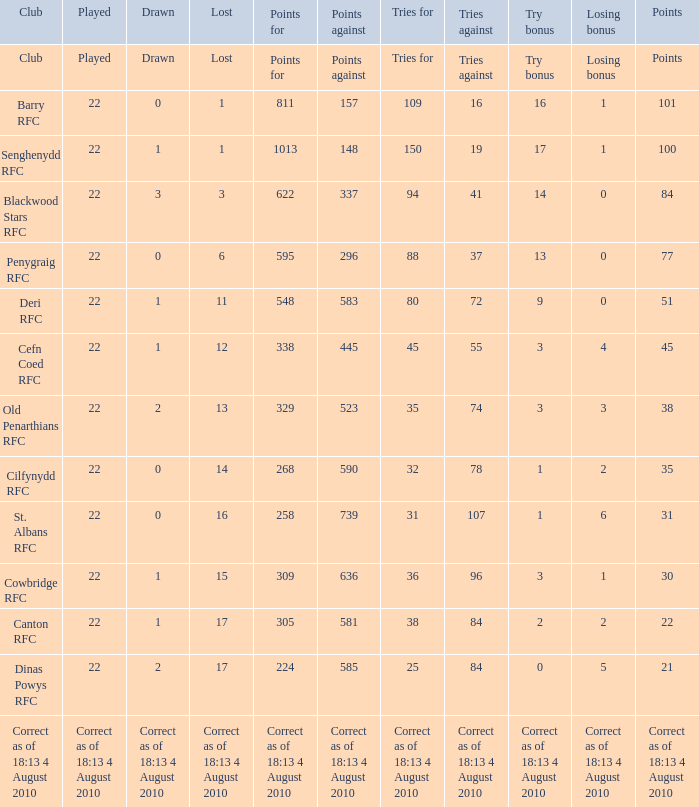What is the name of the club with 22 points? Canton RFC. 